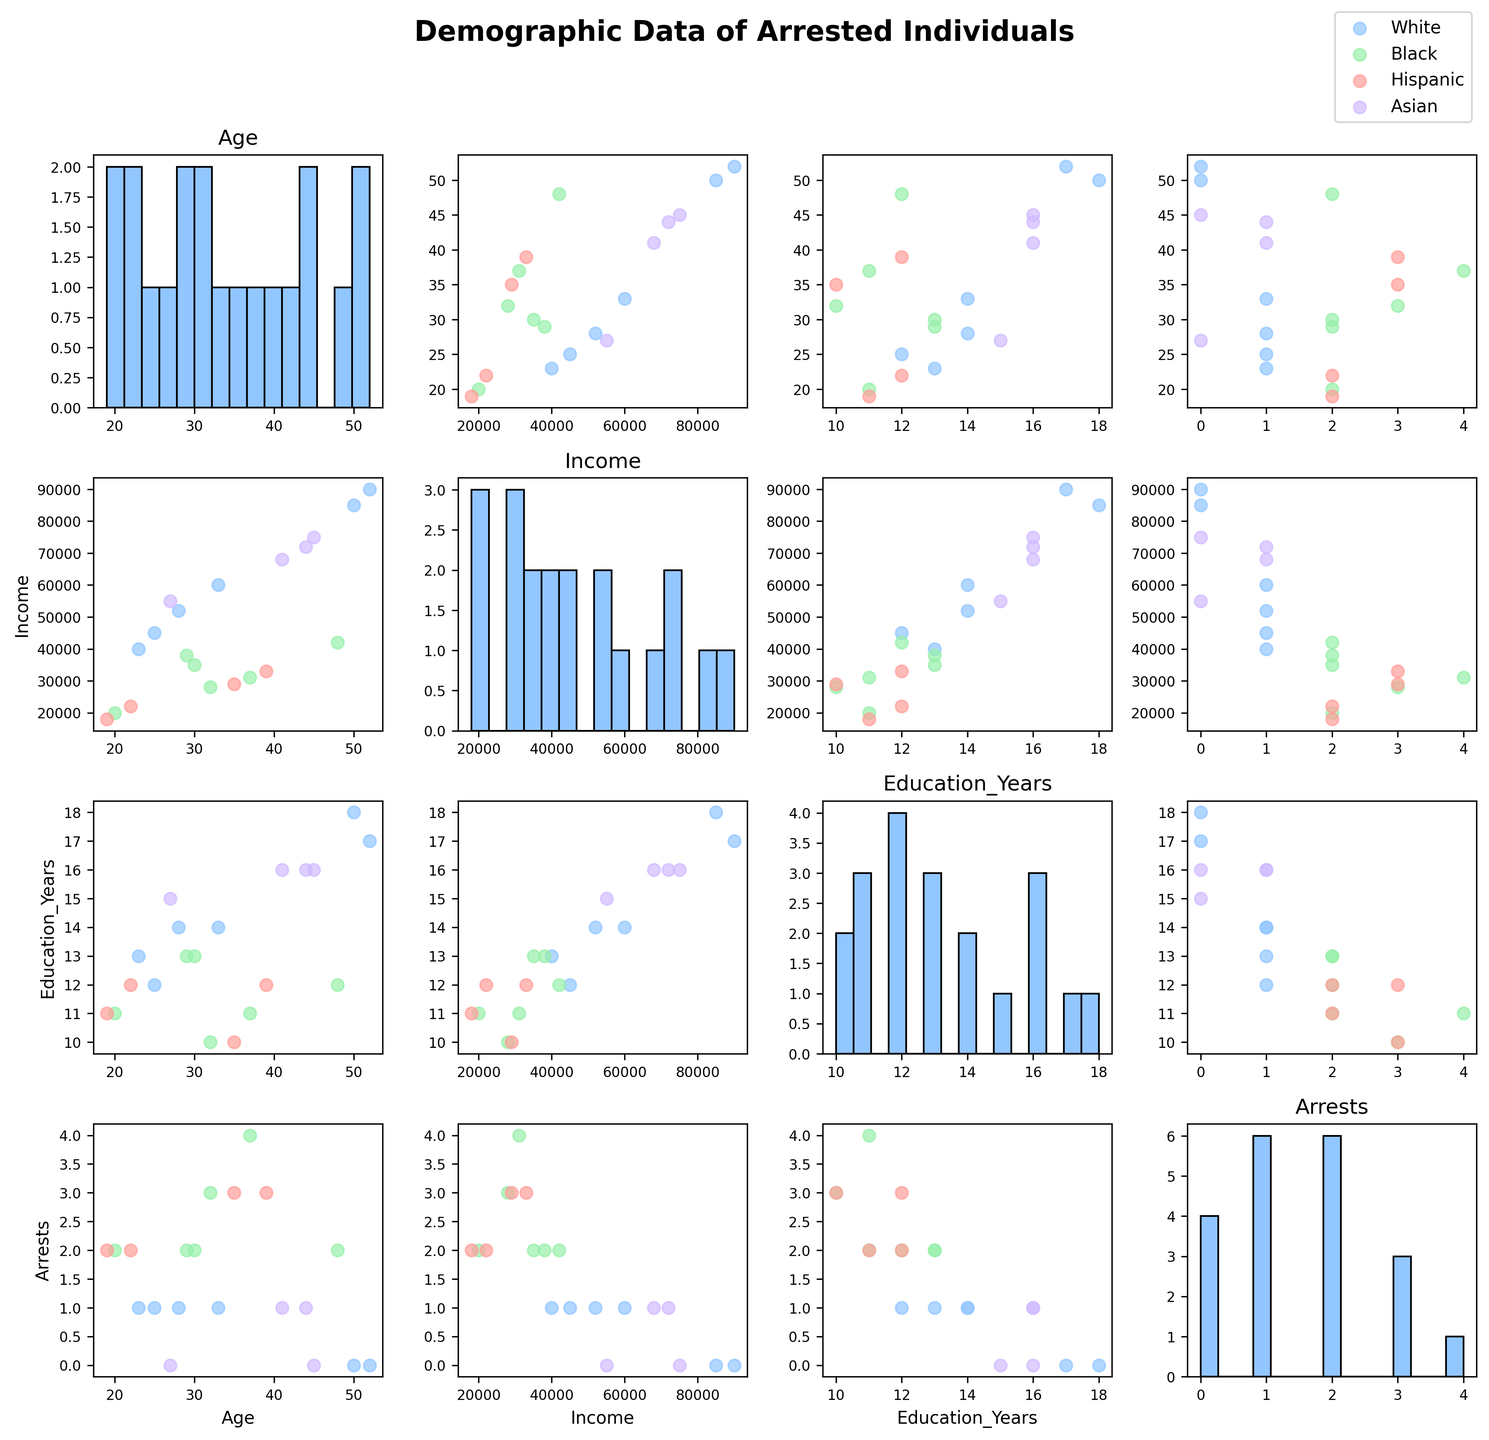What's the title of the figure? The title is displayed at the top of the figure, indicating the nature of the data.
Answer: "Demographic Data of Arrested Individuals" How many different races are represented in the scatterplot? The legend in the upper right of the figure lists the unique races represented as different colors and labels.
Answer: 4 Which variable has the widest range of values in its histogram? By comparing the span of the bars in the histograms along the diagonal, the variable with the widest spread can be determined.
Answer: Income Between which two variables do Asian individuals display the most scatter in their data points? By examining the scatter plots, look for the one with the greatest dispersion of data points for Asian individuals (represented by specific markers).
Answer: Age and Income What's the average number of arrests for individuals with more than 14 years of education? First, identify the scatter plots where Education_Years is plotted on one axis and Arrests on the other. Then, visually estimate the values corresponding to more than 14 years of education and compute the average.
Answer: Approximately 0.67 Do individuals with higher income generally have more or fewer arrests? By observing scatter plots where Income is plotted against Arrests, note the trend of data points to determine the relationship.
Answer: Fewer arrests Which race shows a consistent pattern of fewer arrests with higher ages? Examine scatter plots where Age is plotted against Arrests. Look for a consistent trend where data points for a specific race indicate fewer arrests as age increases.
Answer: White In the scatterplot of Income versus Education_Years, which race seems to have the highest correlation between these two variables? Look for the scatter plot with Income on one axis and Education_Years on the other. Identify which race's data points form the most linear pattern.
Answer: Asian What's the maximum number of arrests recorded in the dataset? By looking at the axes markers in the scatter plots or histograms where the Arrests variable is involved, determine the highest value marked.
Answer: 4 Which race has the highest representation in the dataset, and what visual cue helped you conclude this? The legend provides the labels for each race, and by counting the frequency of data points in the scatter plots, determine which race appears most often.
Answer: White, the abundance of their data points in the figure 